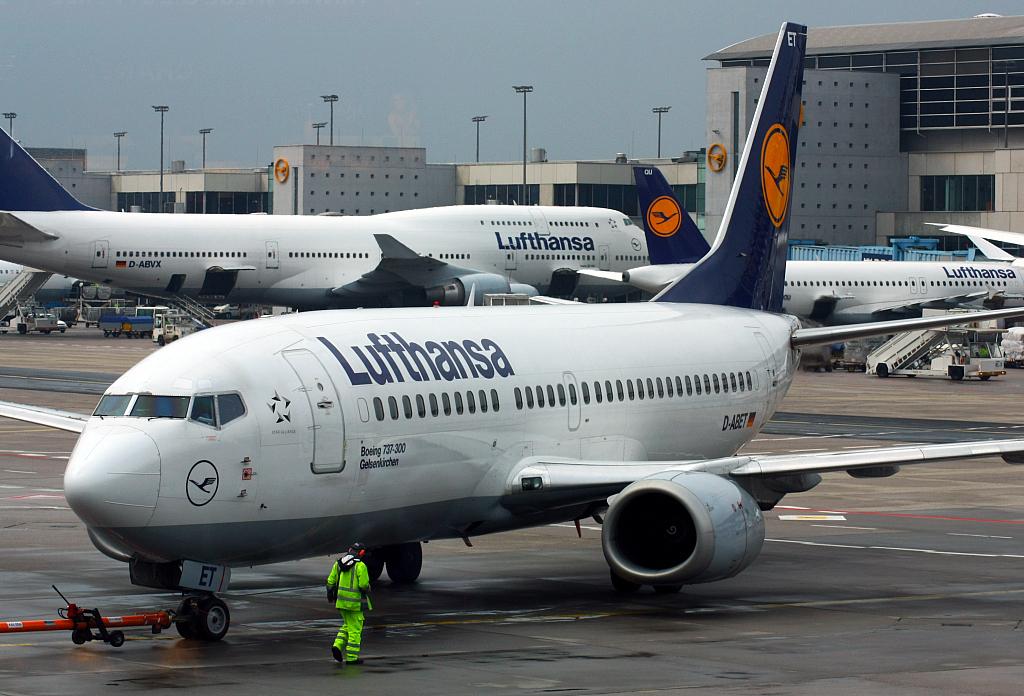What airline is this plane?
Give a very brief answer. Lufthansa. 